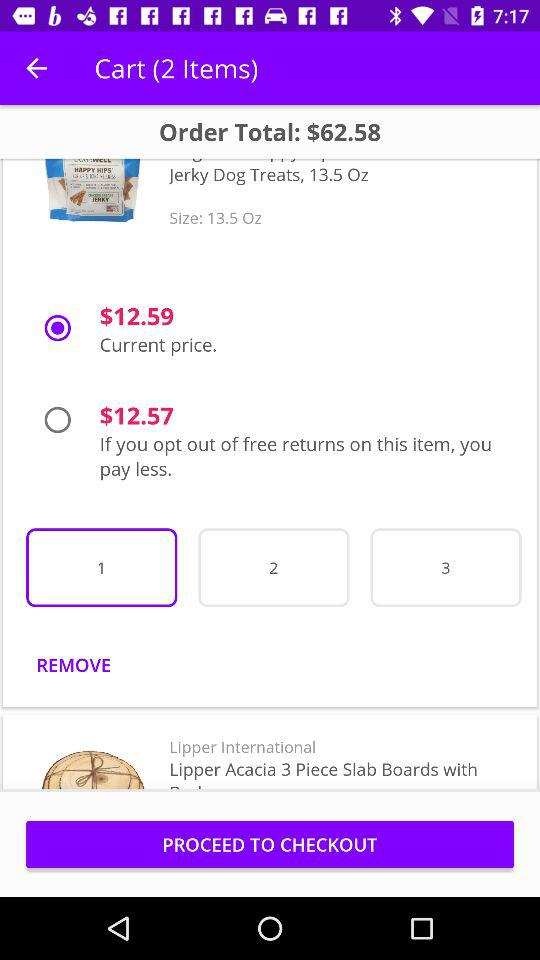What is the selected quantity of the product? The selected quantity of the product is 1. 